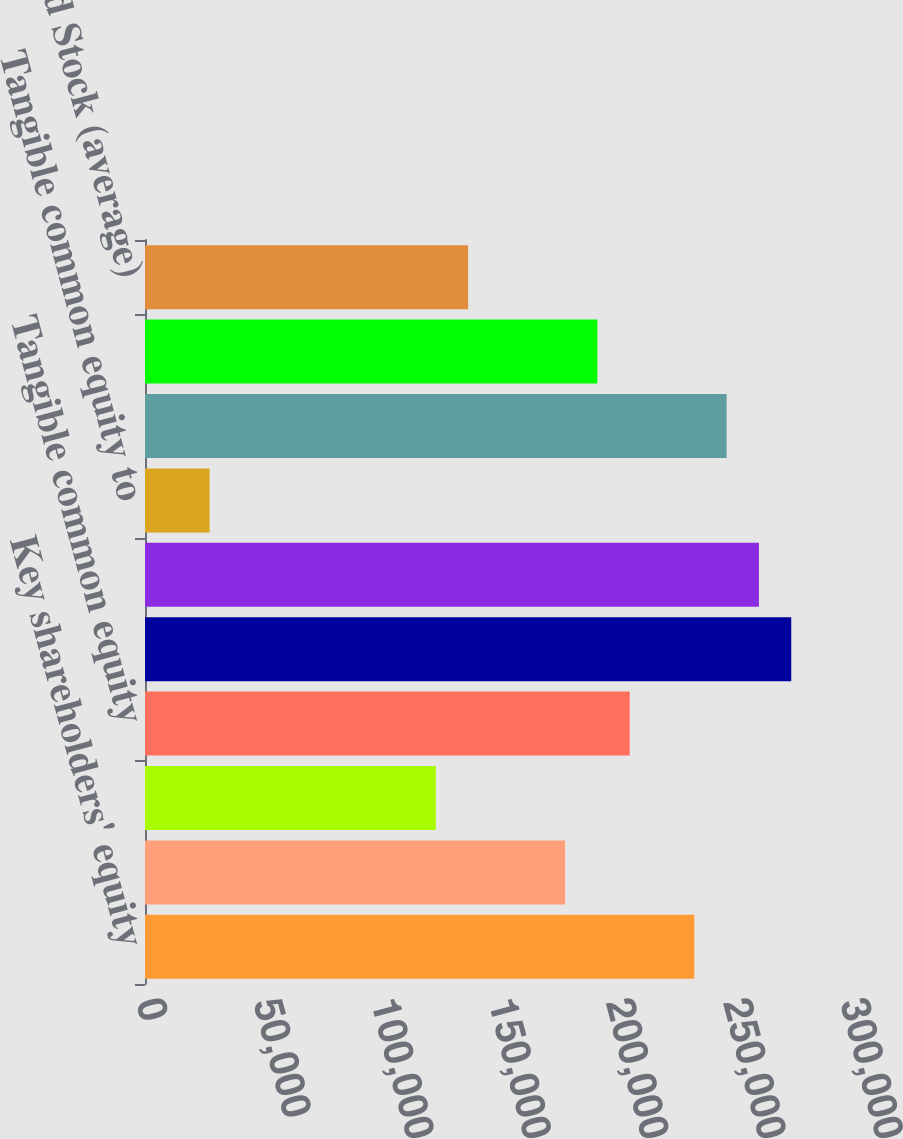<chart> <loc_0><loc_0><loc_500><loc_500><bar_chart><fcel>Key shareholders' equity<fcel>Less Intangible assets (a)<fcel>Preferred Stock (b)<fcel>Tangible common equity<fcel>Total assets (GAAP)<fcel>Tangible assets (non-GAAP)<fcel>Tangible common equity to<fcel>Average Key shareholders'<fcel>Less Intangible assets<fcel>Preferred Stock (average)<nl><fcel>234082<fcel>179006<fcel>123929<fcel>206544<fcel>275390<fcel>261621<fcel>27544.7<fcel>247851<fcel>192775<fcel>137698<nl></chart> 